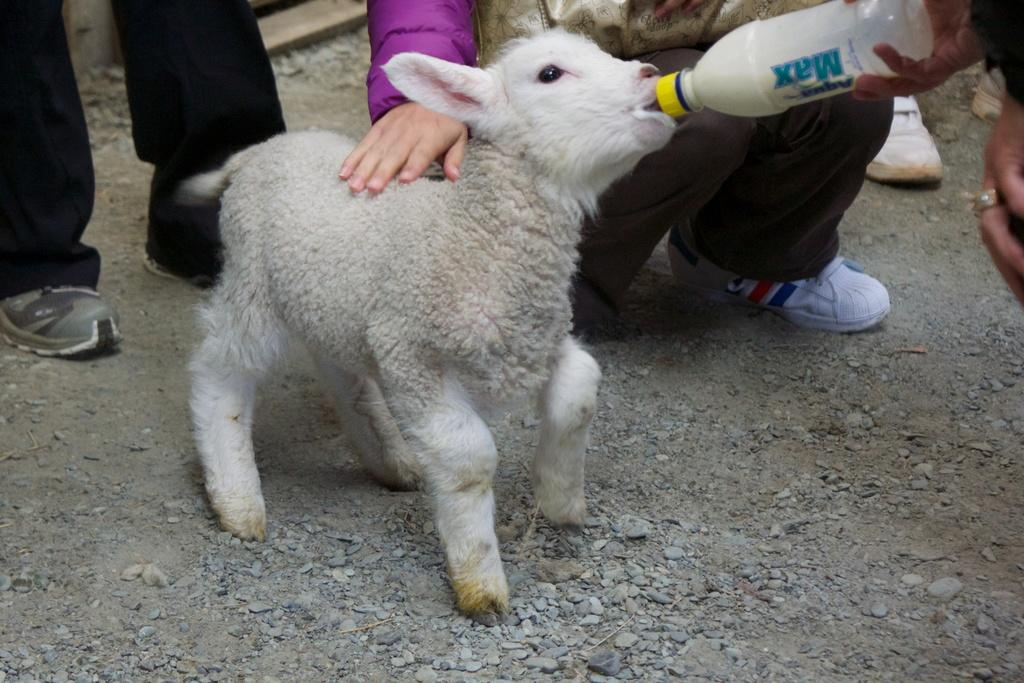What is the main subject in the center of the image? There is a lamb in the center of the image. What is the person's hand holding on the right side of the image? There is a person's hand holding a bottle on the right side of the image. Can you describe the background of the image? There are people visible in the background of the image. What is present at the bottom of the image? There are stones at the bottom of the image. What type of basketball court can be seen in the image? There is no basketball court present in the image. 